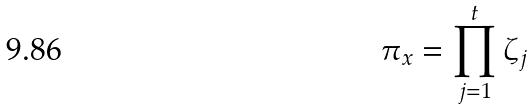Convert formula to latex. <formula><loc_0><loc_0><loc_500><loc_500>\pi _ { x } = \prod _ { j = 1 } ^ { t } \zeta _ { j }</formula> 